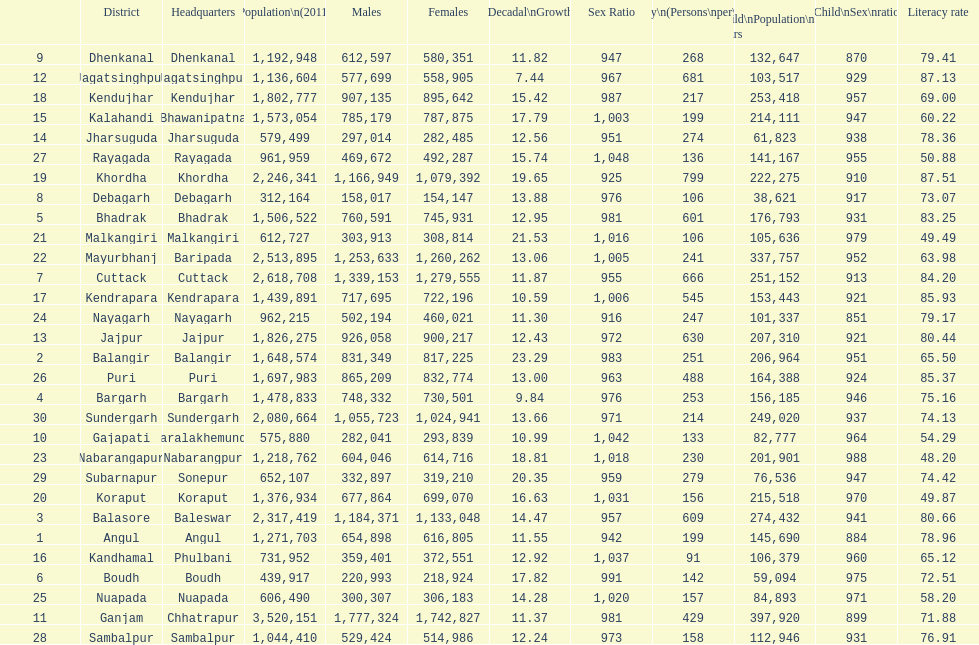Which district has a higher population, angul or cuttack? Cuttack. 